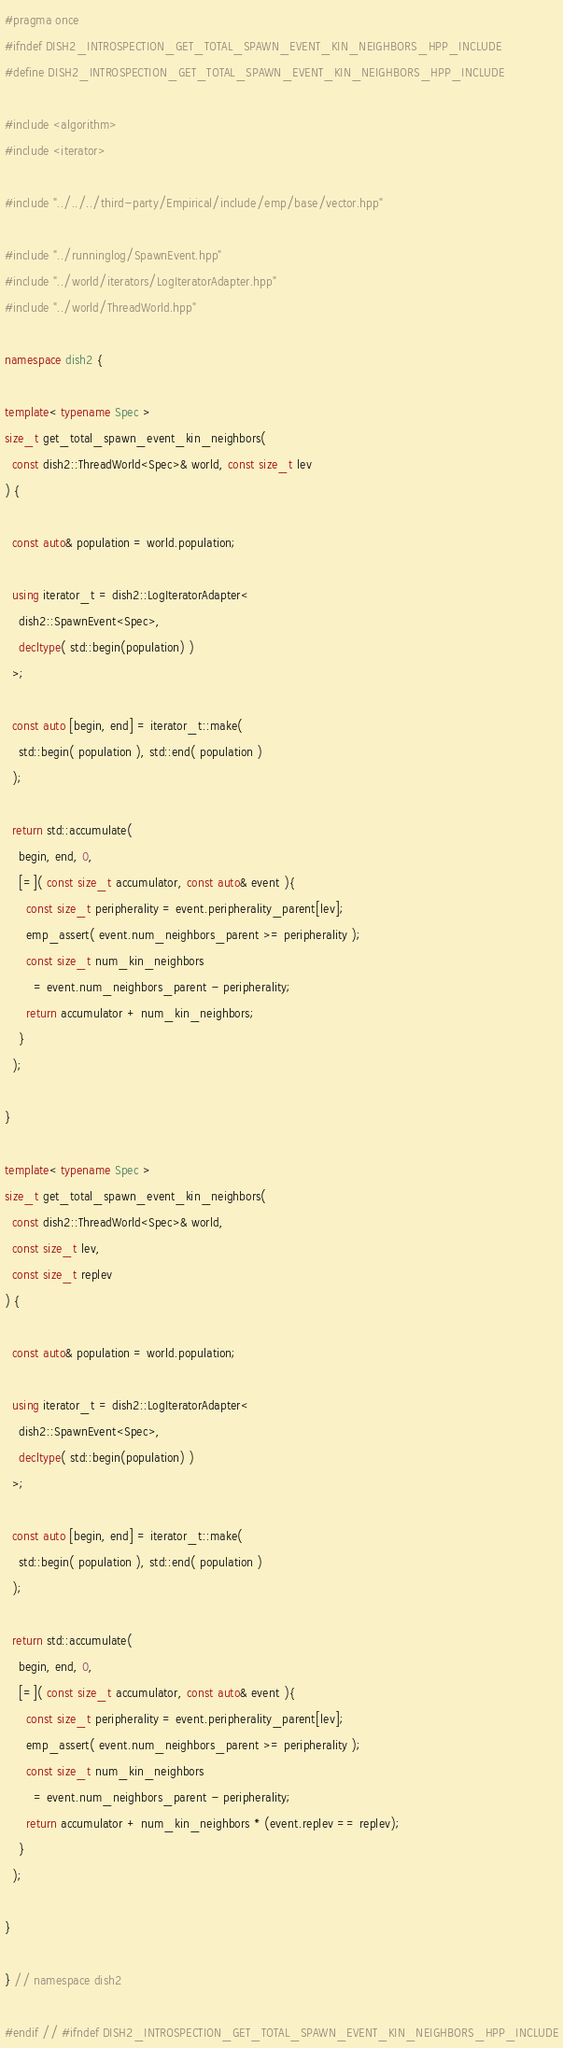<code> <loc_0><loc_0><loc_500><loc_500><_C++_>#pragma once
#ifndef DISH2_INTROSPECTION_GET_TOTAL_SPAWN_EVENT_KIN_NEIGHBORS_HPP_INCLUDE
#define DISH2_INTROSPECTION_GET_TOTAL_SPAWN_EVENT_KIN_NEIGHBORS_HPP_INCLUDE

#include <algorithm>
#include <iterator>

#include "../../../third-party/Empirical/include/emp/base/vector.hpp"

#include "../runninglog/SpawnEvent.hpp"
#include "../world/iterators/LogIteratorAdapter.hpp"
#include "../world/ThreadWorld.hpp"

namespace dish2 {

template< typename Spec >
size_t get_total_spawn_event_kin_neighbors(
  const dish2::ThreadWorld<Spec>& world, const size_t lev
) {

  const auto& population = world.population;

  using iterator_t = dish2::LogIteratorAdapter<
    dish2::SpawnEvent<Spec>,
    decltype( std::begin(population) )
  >;

  const auto [begin, end] = iterator_t::make(
    std::begin( population ), std::end( population )
  );

  return std::accumulate(
    begin, end, 0,
    [=]( const size_t accumulator, const auto& event ){
      const size_t peripherality = event.peripherality_parent[lev];
      emp_assert( event.num_neighbors_parent >= peripherality );
      const size_t num_kin_neighbors
        = event.num_neighbors_parent - peripherality;
      return accumulator + num_kin_neighbors;
    }
  );

}

template< typename Spec >
size_t get_total_spawn_event_kin_neighbors(
  const dish2::ThreadWorld<Spec>& world,
  const size_t lev,
  const size_t replev
) {

  const auto& population = world.population;

  using iterator_t = dish2::LogIteratorAdapter<
    dish2::SpawnEvent<Spec>,
    decltype( std::begin(population) )
  >;

  const auto [begin, end] = iterator_t::make(
    std::begin( population ), std::end( population )
  );

  return std::accumulate(
    begin, end, 0,
    [=]( const size_t accumulator, const auto& event ){
      const size_t peripherality = event.peripherality_parent[lev];
      emp_assert( event.num_neighbors_parent >= peripherality );
      const size_t num_kin_neighbors
        = event.num_neighbors_parent - peripherality;
      return accumulator + num_kin_neighbors * (event.replev == replev);
    }
  );

}

} // namespace dish2

#endif // #ifndef DISH2_INTROSPECTION_GET_TOTAL_SPAWN_EVENT_KIN_NEIGHBORS_HPP_INCLUDE
</code> 